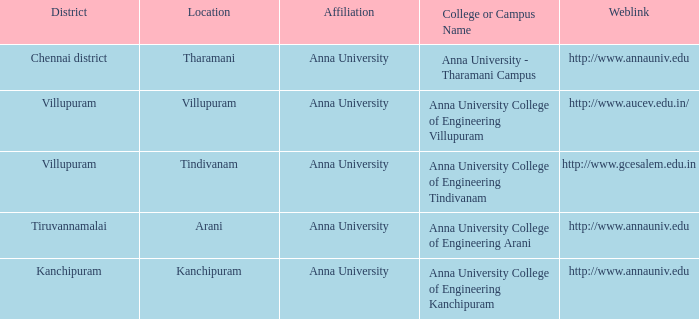Can you provide the weblink for the college or campus called anna university college of engineering tindivanam? Http://www.gcesalem.edu.in. Give me the full table as a dictionary. {'header': ['District', 'Location', 'Affiliation', 'College or Campus Name', 'Weblink'], 'rows': [['Chennai district', 'Tharamani', 'Anna University', 'Anna University - Tharamani Campus', 'http://www.annauniv.edu'], ['Villupuram', 'Villupuram', 'Anna University', 'Anna University College of Engineering Villupuram', 'http://www.aucev.edu.in/'], ['Villupuram', 'Tindivanam', 'Anna University', 'Anna University College of Engineering Tindivanam', 'http://www.gcesalem.edu.in'], ['Tiruvannamalai', 'Arani', 'Anna University', 'Anna University College of Engineering Arani', 'http://www.annauniv.edu'], ['Kanchipuram', 'Kanchipuram', 'Anna University', 'Anna University College of Engineering Kanchipuram', 'http://www.annauniv.edu']]} 